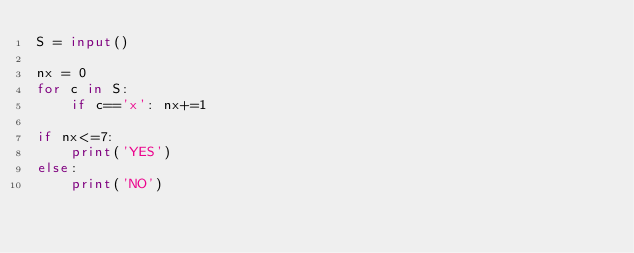<code> <loc_0><loc_0><loc_500><loc_500><_Python_>S = input()

nx = 0
for c in S:
    if c=='x': nx+=1

if nx<=7:
    print('YES')
else:
    print('NO')

</code> 